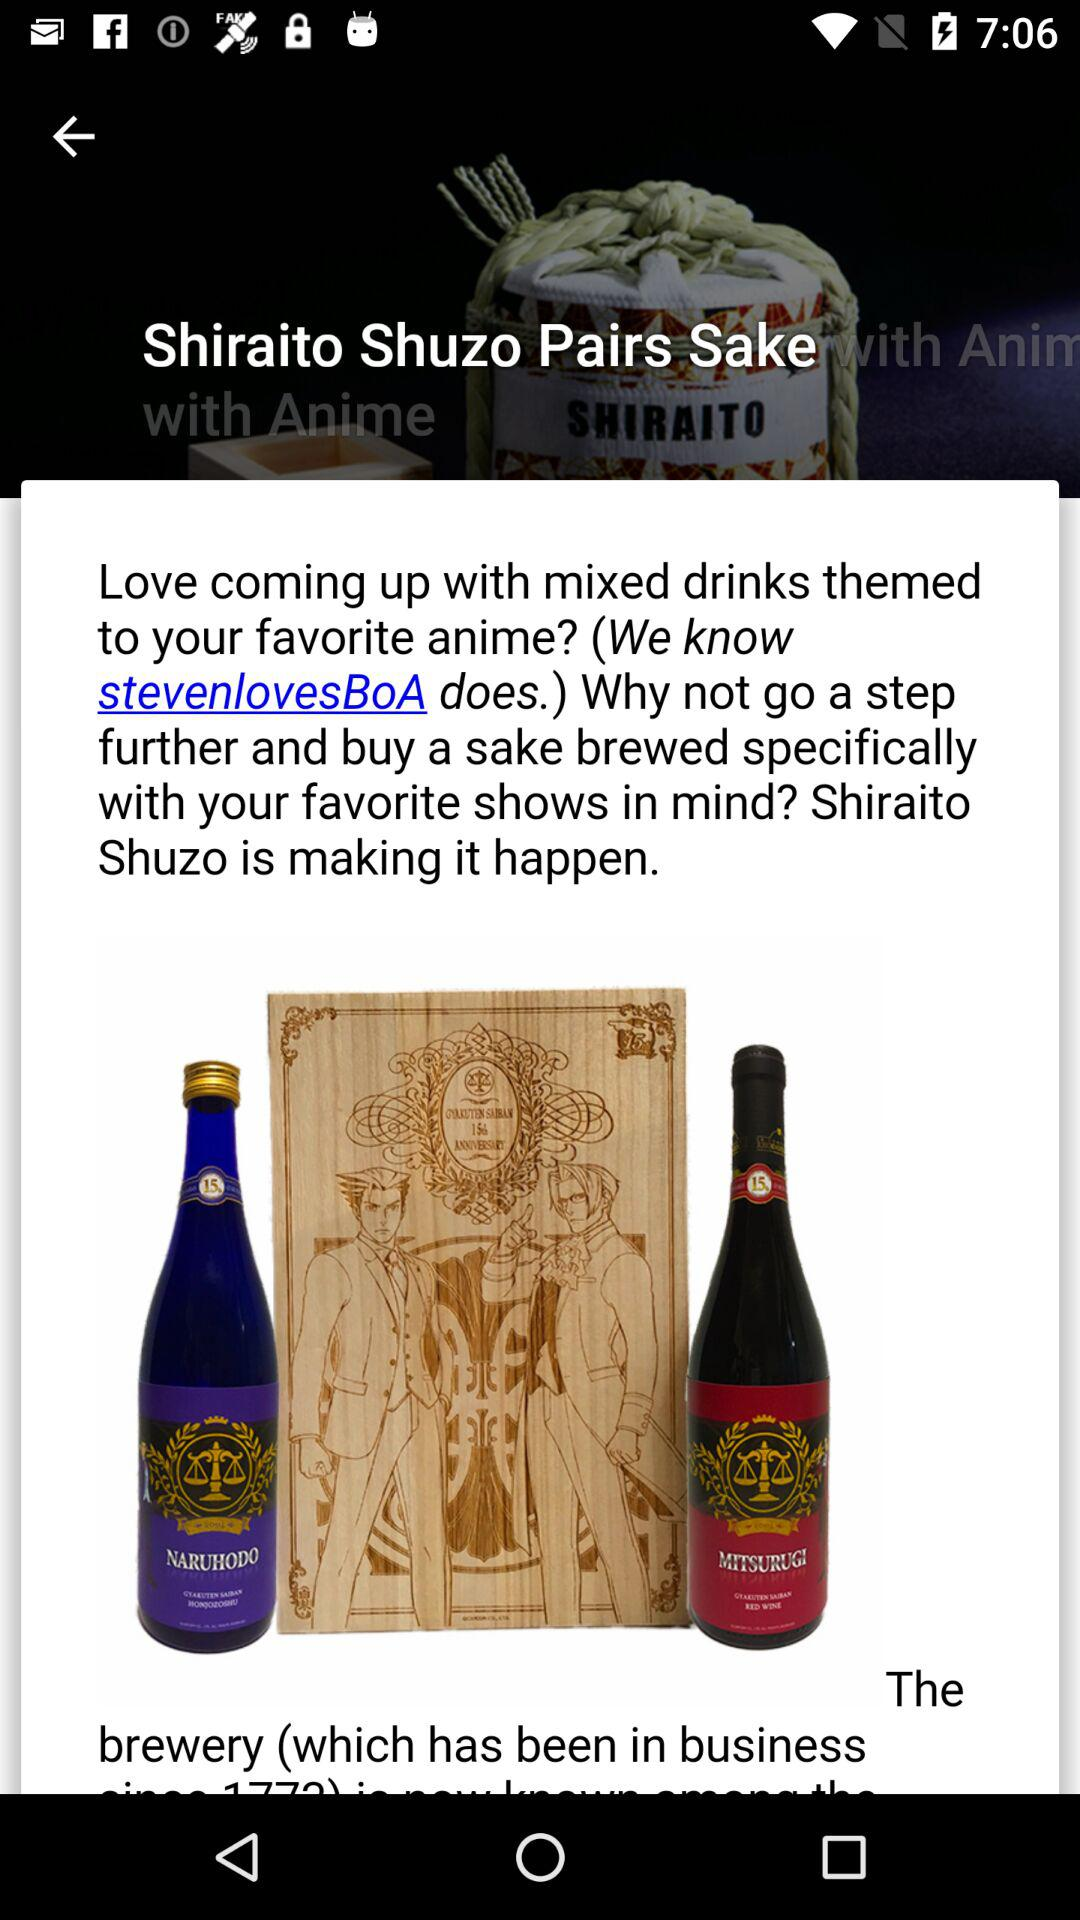What is the name of the sake? The name of the sake is "Shiraito Shuzo Pairs Sake". 